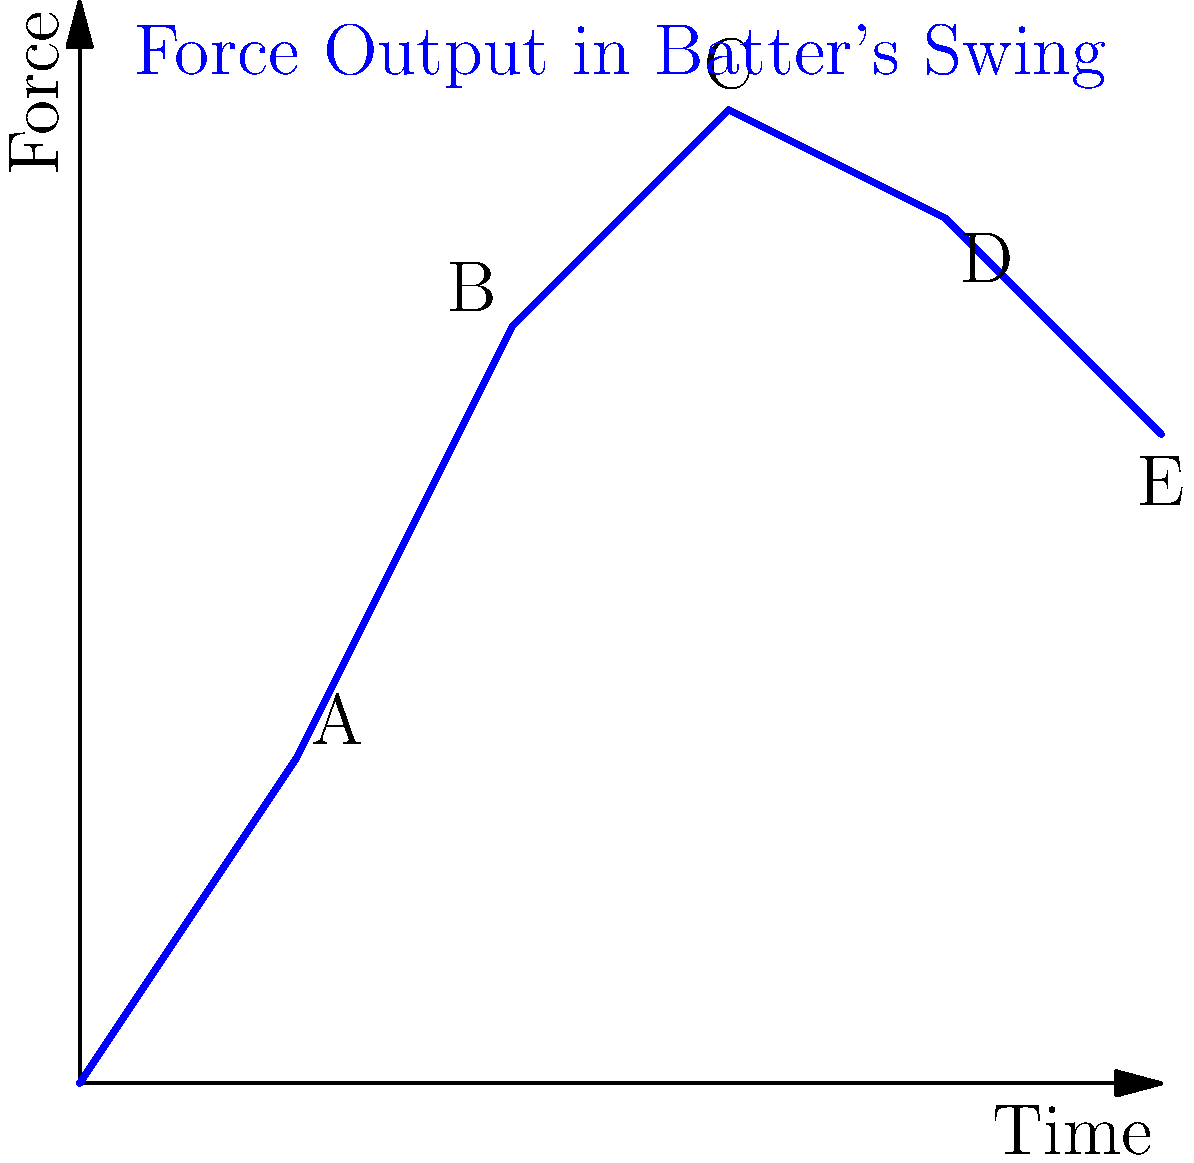As a sports journalist covering the Chicago Cubs, you're analyzing the biomechanics of a batter's swing. The graph shows the force output during different phases of the swing. Which point on the graph likely represents the moment of hip rotation, and why is this crucial for generating power in the swing? To answer this question, let's break down the kinetic chain in a batter's swing and analyze the force output graph:

1. The swing typically begins with leg drive, initiating the kinetic chain.
2. This is followed by hip rotation, which is crucial for generating rotational power.
3. The energy is then transferred through the torso to the shoulders, arms, and finally to the bat.

Analyzing the graph:
- Point A (2,3): Initial force increase, likely representing the start of leg drive.
- Point B (4,7): Steep increase in force, potentially representing hip rotation.
- Point C (6,9): Peak force, likely the point of contact or just before.
- Points D (8,8) and E (10,6): Decreasing force as the swing follows through.

Point B is likely the moment of hip rotation because:
1. It shows a significant increase in force output.
2. It occurs early in the swing sequence, after the initial leg drive but before peak force.
3. Hip rotation is known to be a major contributor to power generation in a baseball swing.

The hip rotation is crucial for generating power because:
1. It creates a separation between the lower and upper body (often called "hip-shoulder separation").
2. This separation stores elastic energy in the core muscles.
3. As the hips rotate, they initiate a powerful rotational movement that transfers energy up the kinetic chain.
4. This rotational power is ultimately transferred to the bat, increasing bat speed and, consequently, the power of the hit.

Understanding this phase of the swing is essential for both players and analysts, as it's often a key differentiator between average and elite hitters.
Answer: Point B, representing hip rotation, crucial for creating hip-shoulder separation and initiating powerful rotational movement. 